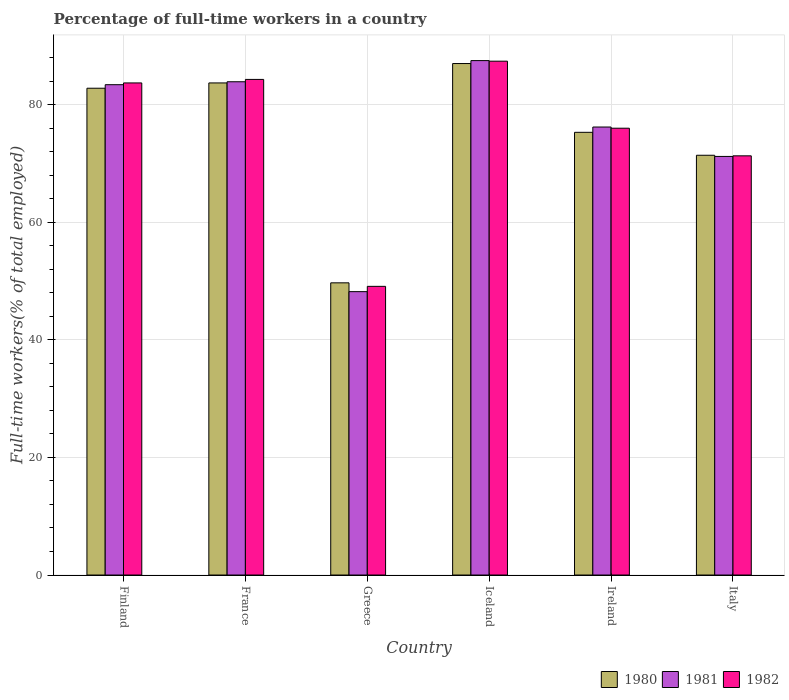How many different coloured bars are there?
Give a very brief answer. 3. Are the number of bars per tick equal to the number of legend labels?
Offer a very short reply. Yes. How many bars are there on the 4th tick from the right?
Make the answer very short. 3. What is the label of the 6th group of bars from the left?
Provide a short and direct response. Italy. In how many cases, is the number of bars for a given country not equal to the number of legend labels?
Make the answer very short. 0. What is the percentage of full-time workers in 1982 in Iceland?
Offer a terse response. 87.4. Across all countries, what is the maximum percentage of full-time workers in 1981?
Offer a very short reply. 87.5. Across all countries, what is the minimum percentage of full-time workers in 1980?
Give a very brief answer. 49.7. In which country was the percentage of full-time workers in 1980 minimum?
Offer a terse response. Greece. What is the total percentage of full-time workers in 1981 in the graph?
Give a very brief answer. 450.4. What is the difference between the percentage of full-time workers in 1982 in Ireland and that in Italy?
Offer a terse response. 4.7. What is the difference between the percentage of full-time workers in 1982 in Iceland and the percentage of full-time workers in 1980 in Greece?
Provide a short and direct response. 37.7. What is the average percentage of full-time workers in 1981 per country?
Offer a terse response. 75.07. What is the difference between the percentage of full-time workers of/in 1982 and percentage of full-time workers of/in 1980 in Italy?
Provide a short and direct response. -0.1. In how many countries, is the percentage of full-time workers in 1980 greater than 56 %?
Ensure brevity in your answer.  5. What is the ratio of the percentage of full-time workers in 1981 in Iceland to that in Italy?
Your response must be concise. 1.23. What is the difference between the highest and the second highest percentage of full-time workers in 1980?
Provide a succinct answer. -0.9. What is the difference between the highest and the lowest percentage of full-time workers in 1980?
Ensure brevity in your answer.  37.3. In how many countries, is the percentage of full-time workers in 1981 greater than the average percentage of full-time workers in 1981 taken over all countries?
Make the answer very short. 4. Is the sum of the percentage of full-time workers in 1980 in France and Italy greater than the maximum percentage of full-time workers in 1981 across all countries?
Give a very brief answer. Yes. What does the 3rd bar from the left in France represents?
Provide a short and direct response. 1982. What does the 2nd bar from the right in Greece represents?
Make the answer very short. 1981. How many bars are there?
Your response must be concise. 18. Are all the bars in the graph horizontal?
Provide a succinct answer. No. How many countries are there in the graph?
Make the answer very short. 6. Are the values on the major ticks of Y-axis written in scientific E-notation?
Your answer should be compact. No. Does the graph contain any zero values?
Offer a terse response. No. What is the title of the graph?
Offer a very short reply. Percentage of full-time workers in a country. What is the label or title of the Y-axis?
Your response must be concise. Full-time workers(% of total employed). What is the Full-time workers(% of total employed) of 1980 in Finland?
Provide a succinct answer. 82.8. What is the Full-time workers(% of total employed) in 1981 in Finland?
Offer a terse response. 83.4. What is the Full-time workers(% of total employed) of 1982 in Finland?
Your answer should be very brief. 83.7. What is the Full-time workers(% of total employed) in 1980 in France?
Provide a succinct answer. 83.7. What is the Full-time workers(% of total employed) of 1981 in France?
Offer a terse response. 83.9. What is the Full-time workers(% of total employed) in 1982 in France?
Offer a terse response. 84.3. What is the Full-time workers(% of total employed) of 1980 in Greece?
Provide a succinct answer. 49.7. What is the Full-time workers(% of total employed) in 1981 in Greece?
Keep it short and to the point. 48.2. What is the Full-time workers(% of total employed) of 1982 in Greece?
Make the answer very short. 49.1. What is the Full-time workers(% of total employed) in 1981 in Iceland?
Your answer should be compact. 87.5. What is the Full-time workers(% of total employed) in 1982 in Iceland?
Your answer should be very brief. 87.4. What is the Full-time workers(% of total employed) in 1980 in Ireland?
Your answer should be very brief. 75.3. What is the Full-time workers(% of total employed) of 1981 in Ireland?
Ensure brevity in your answer.  76.2. What is the Full-time workers(% of total employed) of 1982 in Ireland?
Your response must be concise. 76. What is the Full-time workers(% of total employed) of 1980 in Italy?
Provide a short and direct response. 71.4. What is the Full-time workers(% of total employed) of 1981 in Italy?
Provide a short and direct response. 71.2. What is the Full-time workers(% of total employed) of 1982 in Italy?
Offer a very short reply. 71.3. Across all countries, what is the maximum Full-time workers(% of total employed) of 1980?
Provide a succinct answer. 87. Across all countries, what is the maximum Full-time workers(% of total employed) of 1981?
Offer a terse response. 87.5. Across all countries, what is the maximum Full-time workers(% of total employed) in 1982?
Your answer should be very brief. 87.4. Across all countries, what is the minimum Full-time workers(% of total employed) in 1980?
Keep it short and to the point. 49.7. Across all countries, what is the minimum Full-time workers(% of total employed) in 1981?
Provide a short and direct response. 48.2. Across all countries, what is the minimum Full-time workers(% of total employed) of 1982?
Your response must be concise. 49.1. What is the total Full-time workers(% of total employed) in 1980 in the graph?
Ensure brevity in your answer.  449.9. What is the total Full-time workers(% of total employed) of 1981 in the graph?
Give a very brief answer. 450.4. What is the total Full-time workers(% of total employed) in 1982 in the graph?
Make the answer very short. 451.8. What is the difference between the Full-time workers(% of total employed) of 1980 in Finland and that in France?
Offer a terse response. -0.9. What is the difference between the Full-time workers(% of total employed) of 1980 in Finland and that in Greece?
Your answer should be very brief. 33.1. What is the difference between the Full-time workers(% of total employed) of 1981 in Finland and that in Greece?
Keep it short and to the point. 35.2. What is the difference between the Full-time workers(% of total employed) in 1982 in Finland and that in Greece?
Keep it short and to the point. 34.6. What is the difference between the Full-time workers(% of total employed) of 1980 in Finland and that in Iceland?
Make the answer very short. -4.2. What is the difference between the Full-time workers(% of total employed) in 1980 in Finland and that in Ireland?
Ensure brevity in your answer.  7.5. What is the difference between the Full-time workers(% of total employed) in 1980 in France and that in Greece?
Provide a short and direct response. 34. What is the difference between the Full-time workers(% of total employed) in 1981 in France and that in Greece?
Provide a short and direct response. 35.7. What is the difference between the Full-time workers(% of total employed) in 1982 in France and that in Greece?
Give a very brief answer. 35.2. What is the difference between the Full-time workers(% of total employed) of 1981 in France and that in Iceland?
Provide a short and direct response. -3.6. What is the difference between the Full-time workers(% of total employed) of 1980 in France and that in Ireland?
Keep it short and to the point. 8.4. What is the difference between the Full-time workers(% of total employed) of 1981 in France and that in Ireland?
Your response must be concise. 7.7. What is the difference between the Full-time workers(% of total employed) in 1982 in France and that in Ireland?
Make the answer very short. 8.3. What is the difference between the Full-time workers(% of total employed) of 1980 in France and that in Italy?
Provide a succinct answer. 12.3. What is the difference between the Full-time workers(% of total employed) of 1981 in France and that in Italy?
Your answer should be compact. 12.7. What is the difference between the Full-time workers(% of total employed) in 1982 in France and that in Italy?
Provide a succinct answer. 13. What is the difference between the Full-time workers(% of total employed) of 1980 in Greece and that in Iceland?
Provide a short and direct response. -37.3. What is the difference between the Full-time workers(% of total employed) in 1981 in Greece and that in Iceland?
Provide a succinct answer. -39.3. What is the difference between the Full-time workers(% of total employed) of 1982 in Greece and that in Iceland?
Provide a short and direct response. -38.3. What is the difference between the Full-time workers(% of total employed) in 1980 in Greece and that in Ireland?
Your response must be concise. -25.6. What is the difference between the Full-time workers(% of total employed) in 1981 in Greece and that in Ireland?
Provide a succinct answer. -28. What is the difference between the Full-time workers(% of total employed) in 1982 in Greece and that in Ireland?
Make the answer very short. -26.9. What is the difference between the Full-time workers(% of total employed) of 1980 in Greece and that in Italy?
Your response must be concise. -21.7. What is the difference between the Full-time workers(% of total employed) in 1981 in Greece and that in Italy?
Give a very brief answer. -23. What is the difference between the Full-time workers(% of total employed) of 1982 in Greece and that in Italy?
Offer a terse response. -22.2. What is the difference between the Full-time workers(% of total employed) in 1980 in Iceland and that in Ireland?
Provide a succinct answer. 11.7. What is the difference between the Full-time workers(% of total employed) in 1981 in Iceland and that in Ireland?
Offer a very short reply. 11.3. What is the difference between the Full-time workers(% of total employed) in 1980 in Iceland and that in Italy?
Your answer should be compact. 15.6. What is the difference between the Full-time workers(% of total employed) of 1980 in Finland and the Full-time workers(% of total employed) of 1982 in France?
Keep it short and to the point. -1.5. What is the difference between the Full-time workers(% of total employed) of 1980 in Finland and the Full-time workers(% of total employed) of 1981 in Greece?
Offer a very short reply. 34.6. What is the difference between the Full-time workers(% of total employed) in 1980 in Finland and the Full-time workers(% of total employed) in 1982 in Greece?
Your response must be concise. 33.7. What is the difference between the Full-time workers(% of total employed) of 1981 in Finland and the Full-time workers(% of total employed) of 1982 in Greece?
Offer a very short reply. 34.3. What is the difference between the Full-time workers(% of total employed) of 1980 in Finland and the Full-time workers(% of total employed) of 1981 in Iceland?
Keep it short and to the point. -4.7. What is the difference between the Full-time workers(% of total employed) in 1980 in Finland and the Full-time workers(% of total employed) in 1981 in Ireland?
Offer a terse response. 6.6. What is the difference between the Full-time workers(% of total employed) of 1980 in Finland and the Full-time workers(% of total employed) of 1982 in Ireland?
Your response must be concise. 6.8. What is the difference between the Full-time workers(% of total employed) of 1980 in Finland and the Full-time workers(% of total employed) of 1981 in Italy?
Provide a short and direct response. 11.6. What is the difference between the Full-time workers(% of total employed) in 1980 in Finland and the Full-time workers(% of total employed) in 1982 in Italy?
Make the answer very short. 11.5. What is the difference between the Full-time workers(% of total employed) in 1980 in France and the Full-time workers(% of total employed) in 1981 in Greece?
Offer a very short reply. 35.5. What is the difference between the Full-time workers(% of total employed) in 1980 in France and the Full-time workers(% of total employed) in 1982 in Greece?
Your answer should be compact. 34.6. What is the difference between the Full-time workers(% of total employed) in 1981 in France and the Full-time workers(% of total employed) in 1982 in Greece?
Keep it short and to the point. 34.8. What is the difference between the Full-time workers(% of total employed) in 1980 in France and the Full-time workers(% of total employed) in 1981 in Iceland?
Your answer should be very brief. -3.8. What is the difference between the Full-time workers(% of total employed) of 1981 in France and the Full-time workers(% of total employed) of 1982 in Iceland?
Keep it short and to the point. -3.5. What is the difference between the Full-time workers(% of total employed) of 1980 in France and the Full-time workers(% of total employed) of 1981 in Ireland?
Make the answer very short. 7.5. What is the difference between the Full-time workers(% of total employed) of 1980 in France and the Full-time workers(% of total employed) of 1982 in Ireland?
Provide a short and direct response. 7.7. What is the difference between the Full-time workers(% of total employed) of 1980 in Greece and the Full-time workers(% of total employed) of 1981 in Iceland?
Ensure brevity in your answer.  -37.8. What is the difference between the Full-time workers(% of total employed) of 1980 in Greece and the Full-time workers(% of total employed) of 1982 in Iceland?
Provide a short and direct response. -37.7. What is the difference between the Full-time workers(% of total employed) of 1981 in Greece and the Full-time workers(% of total employed) of 1982 in Iceland?
Offer a very short reply. -39.2. What is the difference between the Full-time workers(% of total employed) of 1980 in Greece and the Full-time workers(% of total employed) of 1981 in Ireland?
Your response must be concise. -26.5. What is the difference between the Full-time workers(% of total employed) in 1980 in Greece and the Full-time workers(% of total employed) in 1982 in Ireland?
Provide a succinct answer. -26.3. What is the difference between the Full-time workers(% of total employed) in 1981 in Greece and the Full-time workers(% of total employed) in 1982 in Ireland?
Offer a very short reply. -27.8. What is the difference between the Full-time workers(% of total employed) in 1980 in Greece and the Full-time workers(% of total employed) in 1981 in Italy?
Keep it short and to the point. -21.5. What is the difference between the Full-time workers(% of total employed) in 1980 in Greece and the Full-time workers(% of total employed) in 1982 in Italy?
Your answer should be very brief. -21.6. What is the difference between the Full-time workers(% of total employed) in 1981 in Greece and the Full-time workers(% of total employed) in 1982 in Italy?
Your answer should be compact. -23.1. What is the difference between the Full-time workers(% of total employed) in 1981 in Iceland and the Full-time workers(% of total employed) in 1982 in Ireland?
Ensure brevity in your answer.  11.5. What is the difference between the Full-time workers(% of total employed) of 1980 in Iceland and the Full-time workers(% of total employed) of 1981 in Italy?
Your answer should be very brief. 15.8. What is the difference between the Full-time workers(% of total employed) in 1981 in Iceland and the Full-time workers(% of total employed) in 1982 in Italy?
Keep it short and to the point. 16.2. What is the difference between the Full-time workers(% of total employed) of 1980 in Ireland and the Full-time workers(% of total employed) of 1982 in Italy?
Keep it short and to the point. 4. What is the average Full-time workers(% of total employed) in 1980 per country?
Offer a very short reply. 74.98. What is the average Full-time workers(% of total employed) of 1981 per country?
Your response must be concise. 75.07. What is the average Full-time workers(% of total employed) in 1982 per country?
Provide a short and direct response. 75.3. What is the difference between the Full-time workers(% of total employed) in 1980 and Full-time workers(% of total employed) in 1981 in Finland?
Make the answer very short. -0.6. What is the difference between the Full-time workers(% of total employed) in 1980 and Full-time workers(% of total employed) in 1982 in Finland?
Keep it short and to the point. -0.9. What is the difference between the Full-time workers(% of total employed) of 1980 and Full-time workers(% of total employed) of 1981 in Greece?
Provide a short and direct response. 1.5. What is the difference between the Full-time workers(% of total employed) in 1980 and Full-time workers(% of total employed) in 1982 in Greece?
Ensure brevity in your answer.  0.6. What is the difference between the Full-time workers(% of total employed) of 1981 and Full-time workers(% of total employed) of 1982 in Greece?
Provide a short and direct response. -0.9. What is the difference between the Full-time workers(% of total employed) in 1980 and Full-time workers(% of total employed) in 1981 in Iceland?
Make the answer very short. -0.5. What is the difference between the Full-time workers(% of total employed) in 1981 and Full-time workers(% of total employed) in 1982 in Iceland?
Give a very brief answer. 0.1. What is the difference between the Full-time workers(% of total employed) in 1980 and Full-time workers(% of total employed) in 1981 in Ireland?
Offer a very short reply. -0.9. What is the difference between the Full-time workers(% of total employed) in 1980 and Full-time workers(% of total employed) in 1982 in Ireland?
Provide a short and direct response. -0.7. What is the difference between the Full-time workers(% of total employed) in 1981 and Full-time workers(% of total employed) in 1982 in Ireland?
Offer a very short reply. 0.2. What is the difference between the Full-time workers(% of total employed) of 1980 and Full-time workers(% of total employed) of 1981 in Italy?
Provide a succinct answer. 0.2. What is the difference between the Full-time workers(% of total employed) in 1981 and Full-time workers(% of total employed) in 1982 in Italy?
Offer a very short reply. -0.1. What is the ratio of the Full-time workers(% of total employed) in 1980 in Finland to that in France?
Your response must be concise. 0.99. What is the ratio of the Full-time workers(% of total employed) of 1982 in Finland to that in France?
Make the answer very short. 0.99. What is the ratio of the Full-time workers(% of total employed) of 1980 in Finland to that in Greece?
Your answer should be very brief. 1.67. What is the ratio of the Full-time workers(% of total employed) of 1981 in Finland to that in Greece?
Offer a terse response. 1.73. What is the ratio of the Full-time workers(% of total employed) in 1982 in Finland to that in Greece?
Provide a short and direct response. 1.7. What is the ratio of the Full-time workers(% of total employed) in 1980 in Finland to that in Iceland?
Keep it short and to the point. 0.95. What is the ratio of the Full-time workers(% of total employed) in 1981 in Finland to that in Iceland?
Give a very brief answer. 0.95. What is the ratio of the Full-time workers(% of total employed) in 1982 in Finland to that in Iceland?
Give a very brief answer. 0.96. What is the ratio of the Full-time workers(% of total employed) of 1980 in Finland to that in Ireland?
Your answer should be very brief. 1.1. What is the ratio of the Full-time workers(% of total employed) in 1981 in Finland to that in Ireland?
Provide a succinct answer. 1.09. What is the ratio of the Full-time workers(% of total employed) of 1982 in Finland to that in Ireland?
Ensure brevity in your answer.  1.1. What is the ratio of the Full-time workers(% of total employed) in 1980 in Finland to that in Italy?
Offer a very short reply. 1.16. What is the ratio of the Full-time workers(% of total employed) in 1981 in Finland to that in Italy?
Your answer should be very brief. 1.17. What is the ratio of the Full-time workers(% of total employed) of 1982 in Finland to that in Italy?
Provide a short and direct response. 1.17. What is the ratio of the Full-time workers(% of total employed) of 1980 in France to that in Greece?
Your response must be concise. 1.68. What is the ratio of the Full-time workers(% of total employed) of 1981 in France to that in Greece?
Give a very brief answer. 1.74. What is the ratio of the Full-time workers(% of total employed) in 1982 in France to that in Greece?
Offer a very short reply. 1.72. What is the ratio of the Full-time workers(% of total employed) in 1980 in France to that in Iceland?
Offer a terse response. 0.96. What is the ratio of the Full-time workers(% of total employed) of 1981 in France to that in Iceland?
Provide a succinct answer. 0.96. What is the ratio of the Full-time workers(% of total employed) in 1982 in France to that in Iceland?
Provide a short and direct response. 0.96. What is the ratio of the Full-time workers(% of total employed) in 1980 in France to that in Ireland?
Ensure brevity in your answer.  1.11. What is the ratio of the Full-time workers(% of total employed) in 1981 in France to that in Ireland?
Provide a short and direct response. 1.1. What is the ratio of the Full-time workers(% of total employed) of 1982 in France to that in Ireland?
Your response must be concise. 1.11. What is the ratio of the Full-time workers(% of total employed) in 1980 in France to that in Italy?
Your answer should be very brief. 1.17. What is the ratio of the Full-time workers(% of total employed) of 1981 in France to that in Italy?
Offer a terse response. 1.18. What is the ratio of the Full-time workers(% of total employed) in 1982 in France to that in Italy?
Your response must be concise. 1.18. What is the ratio of the Full-time workers(% of total employed) in 1980 in Greece to that in Iceland?
Offer a terse response. 0.57. What is the ratio of the Full-time workers(% of total employed) of 1981 in Greece to that in Iceland?
Provide a succinct answer. 0.55. What is the ratio of the Full-time workers(% of total employed) of 1982 in Greece to that in Iceland?
Provide a short and direct response. 0.56. What is the ratio of the Full-time workers(% of total employed) in 1980 in Greece to that in Ireland?
Your answer should be compact. 0.66. What is the ratio of the Full-time workers(% of total employed) of 1981 in Greece to that in Ireland?
Ensure brevity in your answer.  0.63. What is the ratio of the Full-time workers(% of total employed) of 1982 in Greece to that in Ireland?
Your answer should be very brief. 0.65. What is the ratio of the Full-time workers(% of total employed) of 1980 in Greece to that in Italy?
Your answer should be very brief. 0.7. What is the ratio of the Full-time workers(% of total employed) of 1981 in Greece to that in Italy?
Provide a succinct answer. 0.68. What is the ratio of the Full-time workers(% of total employed) of 1982 in Greece to that in Italy?
Provide a short and direct response. 0.69. What is the ratio of the Full-time workers(% of total employed) in 1980 in Iceland to that in Ireland?
Give a very brief answer. 1.16. What is the ratio of the Full-time workers(% of total employed) in 1981 in Iceland to that in Ireland?
Keep it short and to the point. 1.15. What is the ratio of the Full-time workers(% of total employed) in 1982 in Iceland to that in Ireland?
Keep it short and to the point. 1.15. What is the ratio of the Full-time workers(% of total employed) in 1980 in Iceland to that in Italy?
Your answer should be very brief. 1.22. What is the ratio of the Full-time workers(% of total employed) in 1981 in Iceland to that in Italy?
Ensure brevity in your answer.  1.23. What is the ratio of the Full-time workers(% of total employed) in 1982 in Iceland to that in Italy?
Offer a very short reply. 1.23. What is the ratio of the Full-time workers(% of total employed) of 1980 in Ireland to that in Italy?
Offer a terse response. 1.05. What is the ratio of the Full-time workers(% of total employed) of 1981 in Ireland to that in Italy?
Keep it short and to the point. 1.07. What is the ratio of the Full-time workers(% of total employed) of 1982 in Ireland to that in Italy?
Offer a terse response. 1.07. What is the difference between the highest and the lowest Full-time workers(% of total employed) of 1980?
Your answer should be very brief. 37.3. What is the difference between the highest and the lowest Full-time workers(% of total employed) of 1981?
Provide a succinct answer. 39.3. What is the difference between the highest and the lowest Full-time workers(% of total employed) of 1982?
Make the answer very short. 38.3. 